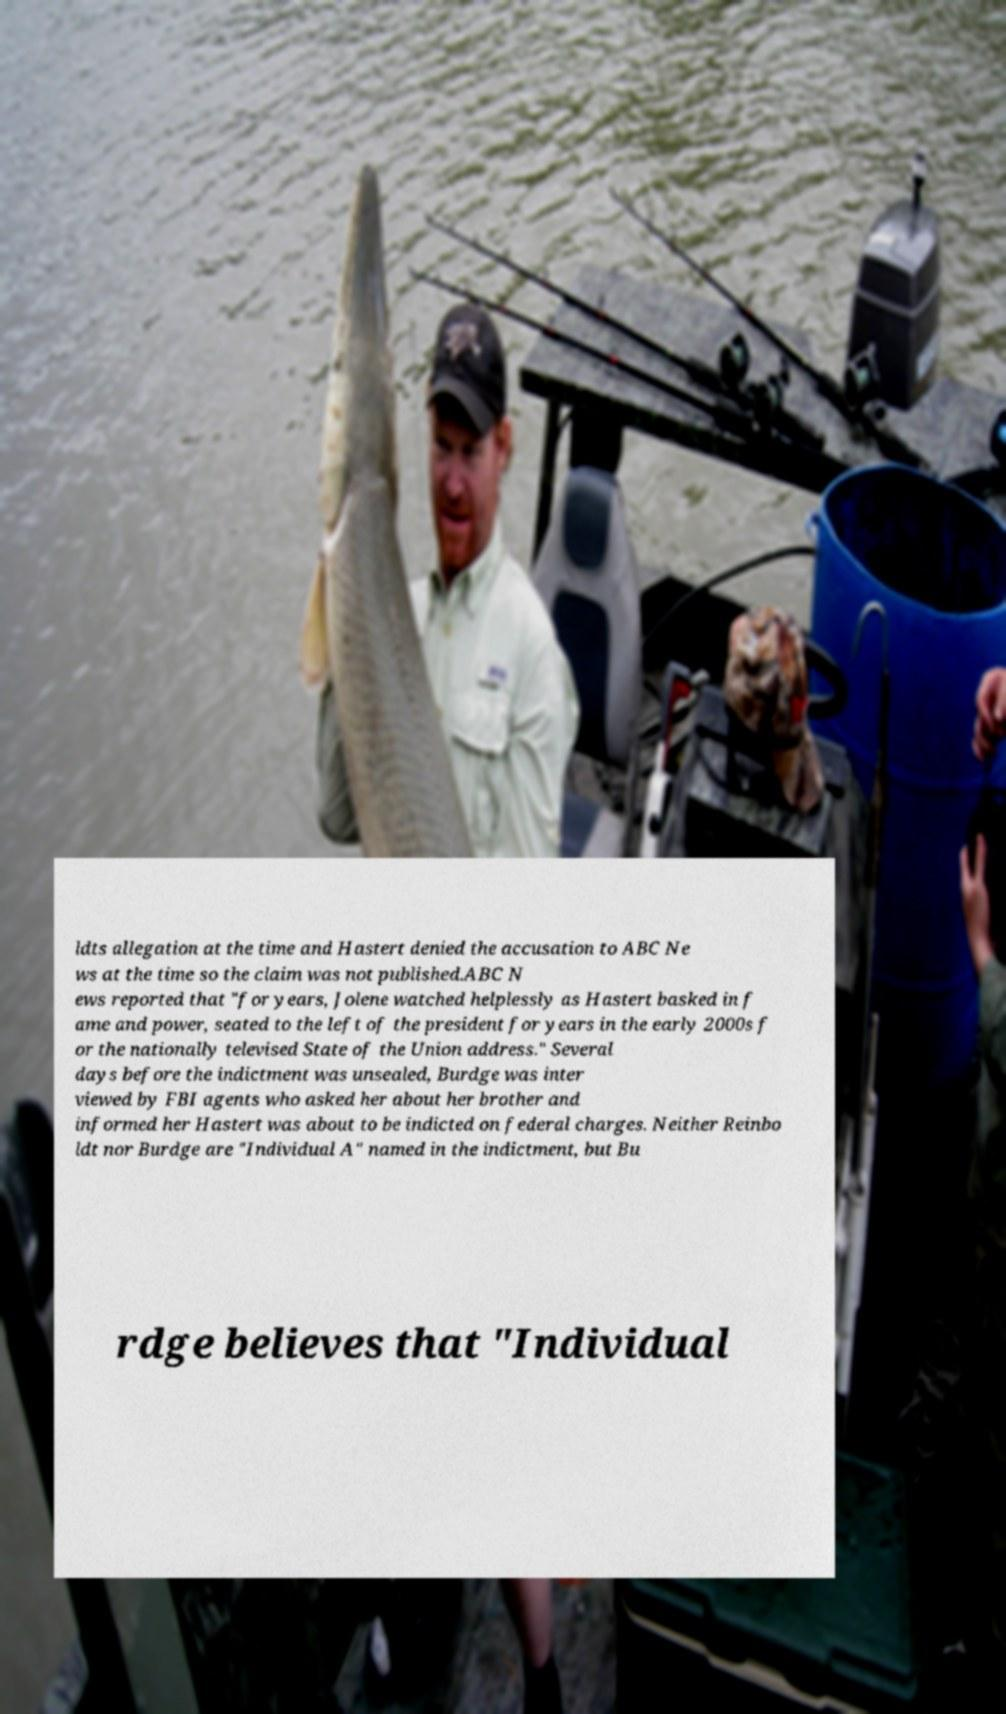What messages or text are displayed in this image? I need them in a readable, typed format. ldts allegation at the time and Hastert denied the accusation to ABC Ne ws at the time so the claim was not published.ABC N ews reported that "for years, Jolene watched helplessly as Hastert basked in f ame and power, seated to the left of the president for years in the early 2000s f or the nationally televised State of the Union address." Several days before the indictment was unsealed, Burdge was inter viewed by FBI agents who asked her about her brother and informed her Hastert was about to be indicted on federal charges. Neither Reinbo ldt nor Burdge are "Individual A" named in the indictment, but Bu rdge believes that "Individual 